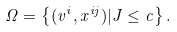Convert formula to latex. <formula><loc_0><loc_0><loc_500><loc_500>\Omega = \left \{ ( v ^ { i } , x ^ { i j } ) | J \leq c \right \} .</formula> 